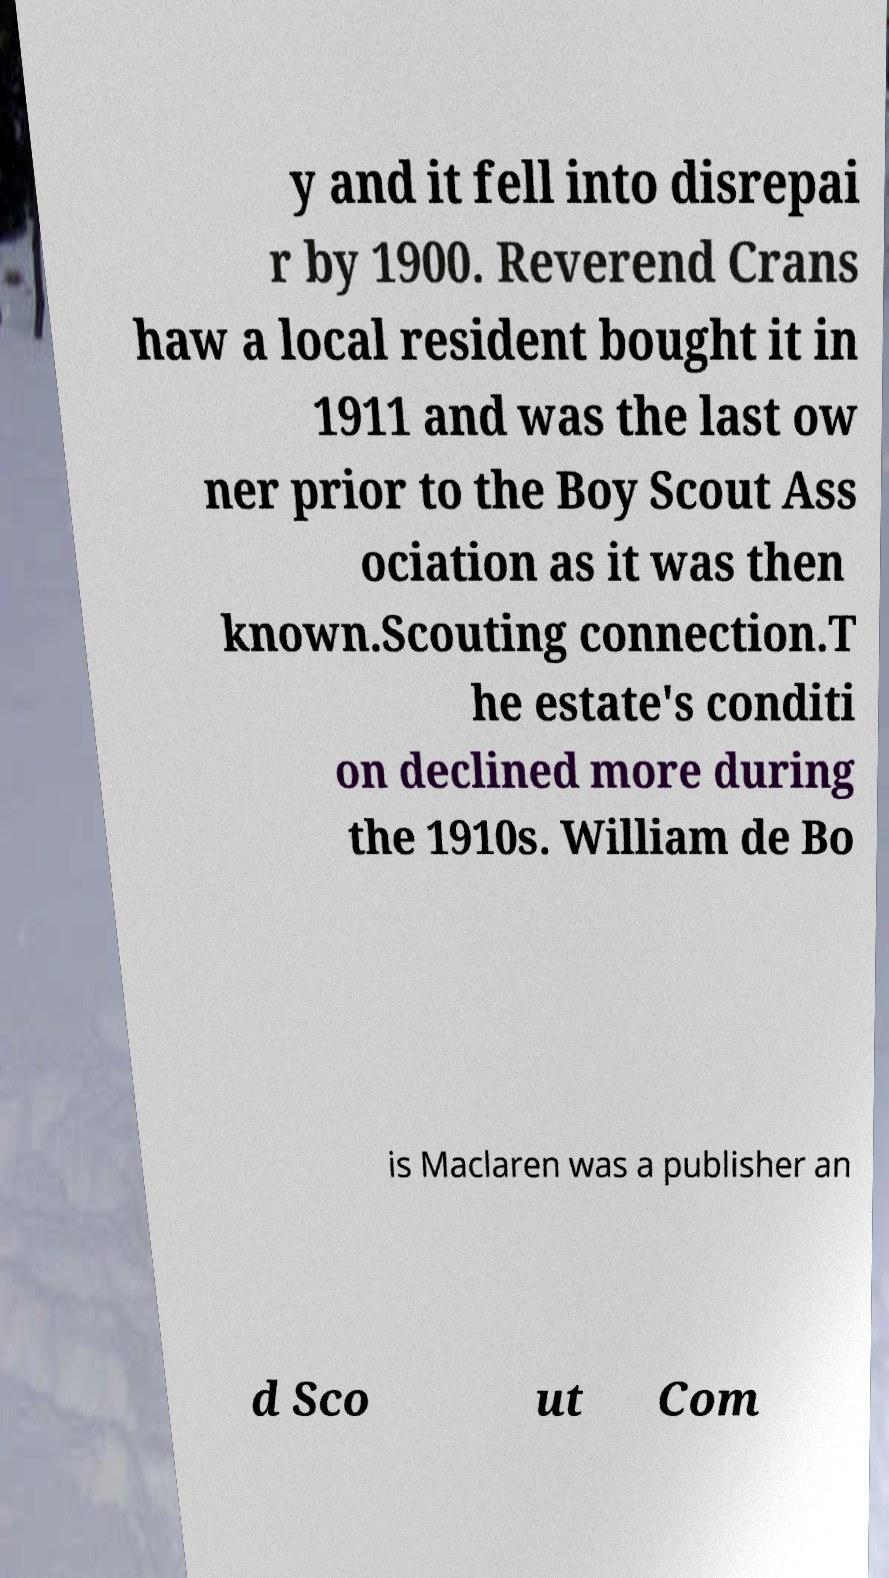What messages or text are displayed in this image? I need them in a readable, typed format. y and it fell into disrepai r by 1900. Reverend Crans haw a local resident bought it in 1911 and was the last ow ner prior to the Boy Scout Ass ociation as it was then known.Scouting connection.T he estate's conditi on declined more during the 1910s. William de Bo is Maclaren was a publisher an d Sco ut Com 